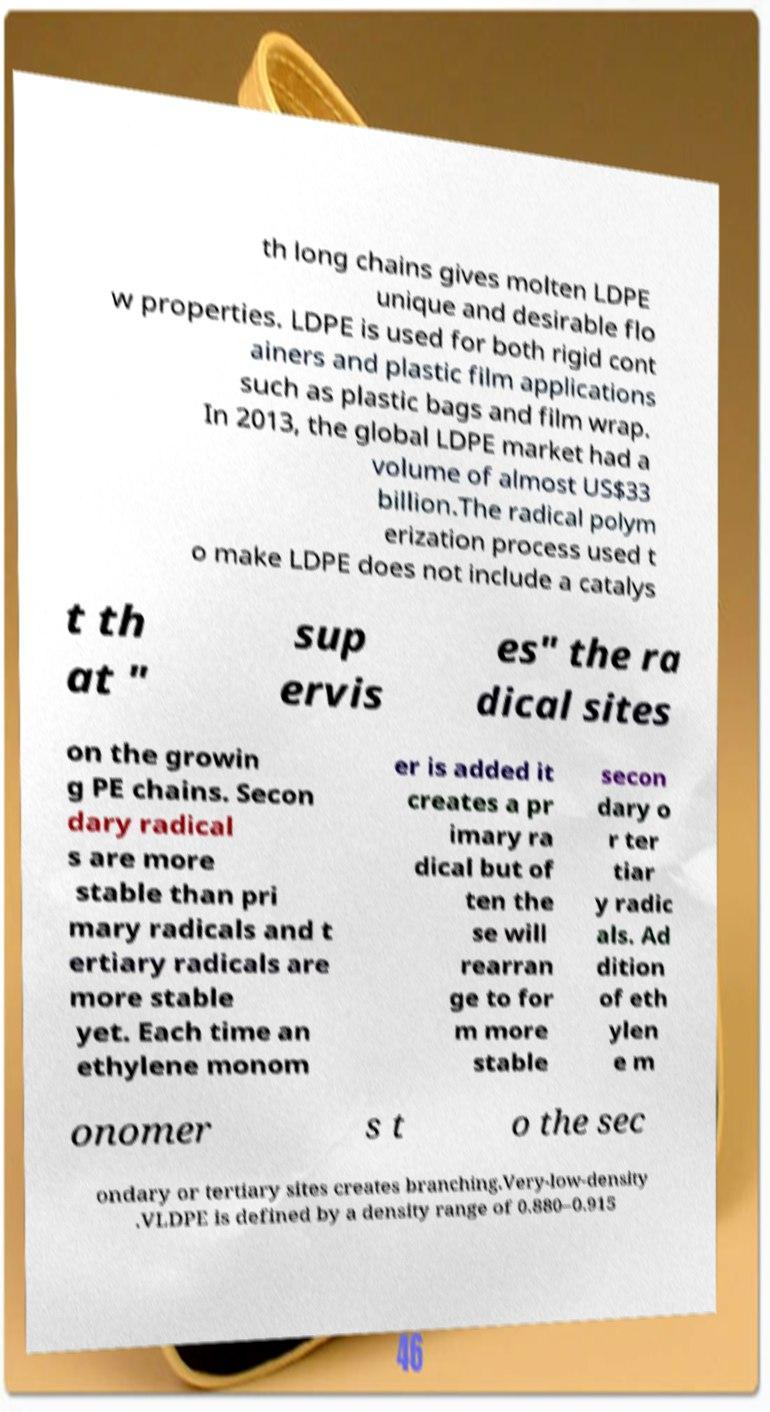What messages or text are displayed in this image? I need them in a readable, typed format. th long chains gives molten LDPE unique and desirable flo w properties. LDPE is used for both rigid cont ainers and plastic film applications such as plastic bags and film wrap. In 2013, the global LDPE market had a volume of almost US$33 billion.The radical polym erization process used t o make LDPE does not include a catalys t th at " sup ervis es" the ra dical sites on the growin g PE chains. Secon dary radical s are more stable than pri mary radicals and t ertiary radicals are more stable yet. Each time an ethylene monom er is added it creates a pr imary ra dical but of ten the se will rearran ge to for m more stable secon dary o r ter tiar y radic als. Ad dition of eth ylen e m onomer s t o the sec ondary or tertiary sites creates branching.Very-low-density .VLDPE is defined by a density range of 0.880–0.915 